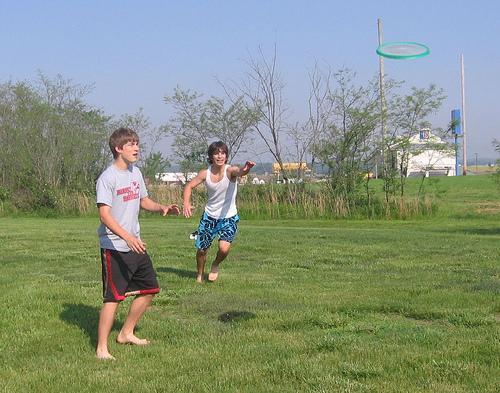How many people are in the picture?
Give a very brief answer. 2. How many children do you see?
Give a very brief answer. 2. 